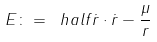Convert formula to latex. <formula><loc_0><loc_0><loc_500><loc_500>E \colon = \ h a l f \dot { r } \cdot \dot { r } - \frac { \mu } { r }</formula> 